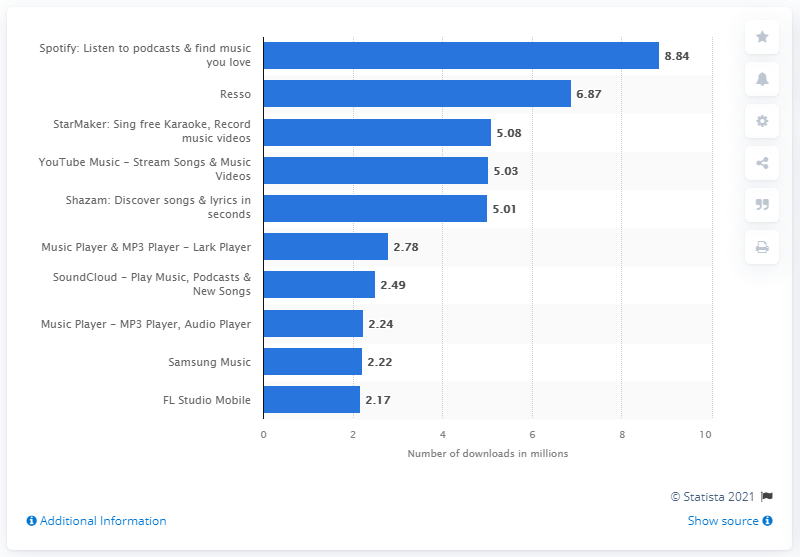Give some essential details in this illustration. In May 2021, Spotify received approximately 8.84 downloads from Android users. What was the second most popular music and audio app in the Google Play Store? It was Resso. 